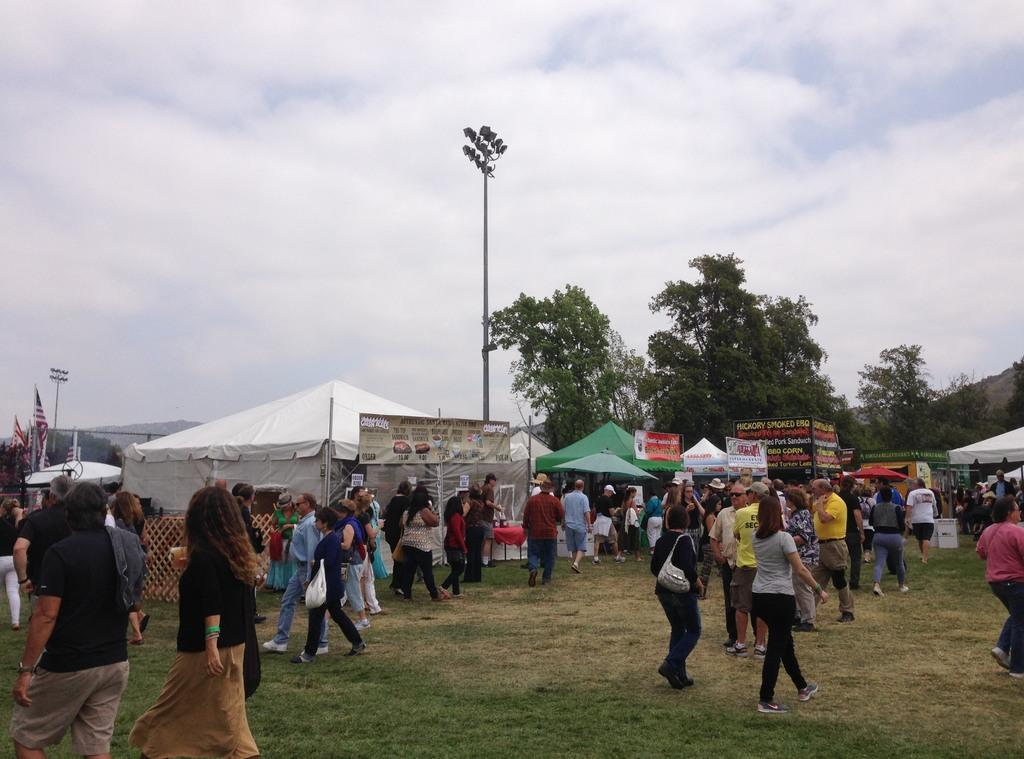What is the main subject in the foreground of the image? There is a crowd in the foreground of the image. What is the crowd standing on? The crowd is on grass. What other structures or objects are present in the foreground of the image? There are tents, boards, flag poles, and street lights in the foreground of the image. What type of vegetation is visible in the foreground of the image? Trees are present in the foreground of the image. What is visible at the top of the image? The sky is visible at the top of the image. Can you determine the time of day the image was taken? The image is likely taken during the day, as there is no indication of darkness or artificial lighting. How many cars are visible in the image? There are no cars visible in the image. What type of air is being used to propel the cannon in the image? There is no cannon present in the image. 